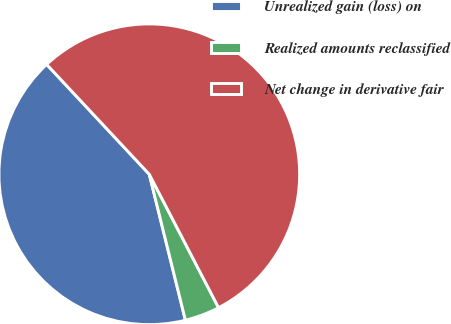Convert chart. <chart><loc_0><loc_0><loc_500><loc_500><pie_chart><fcel>Unrealized gain (loss) on<fcel>Realized amounts reclassified<fcel>Net change in derivative fair<nl><fcel>41.91%<fcel>3.76%<fcel>54.34%<nl></chart> 